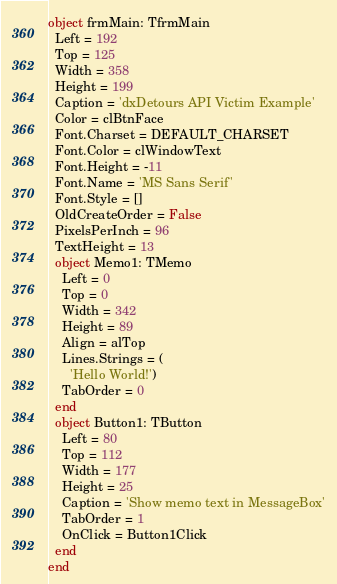Convert code to text. <code><loc_0><loc_0><loc_500><loc_500><_Pascal_>object frmMain: TfrmMain
  Left = 192
  Top = 125
  Width = 358
  Height = 199
  Caption = 'dxDetours API Victim Example'
  Color = clBtnFace
  Font.Charset = DEFAULT_CHARSET
  Font.Color = clWindowText
  Font.Height = -11
  Font.Name = 'MS Sans Serif'
  Font.Style = []
  OldCreateOrder = False
  PixelsPerInch = 96
  TextHeight = 13
  object Memo1: TMemo
    Left = 0
    Top = 0
    Width = 342
    Height = 89
    Align = alTop
    Lines.Strings = (
      'Hello World!')
    TabOrder = 0
  end
  object Button1: TButton
    Left = 80
    Top = 112
    Width = 177
    Height = 25
    Caption = 'Show memo text in MessageBox'
    TabOrder = 1
    OnClick = Button1Click
  end
end
</code> 